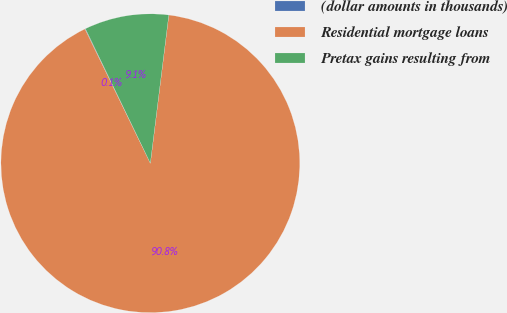Convert chart to OTSL. <chart><loc_0><loc_0><loc_500><loc_500><pie_chart><fcel>(dollar amounts in thousands)<fcel>Residential mortgage loans<fcel>Pretax gains resulting from<nl><fcel>0.06%<fcel>90.81%<fcel>9.13%<nl></chart> 